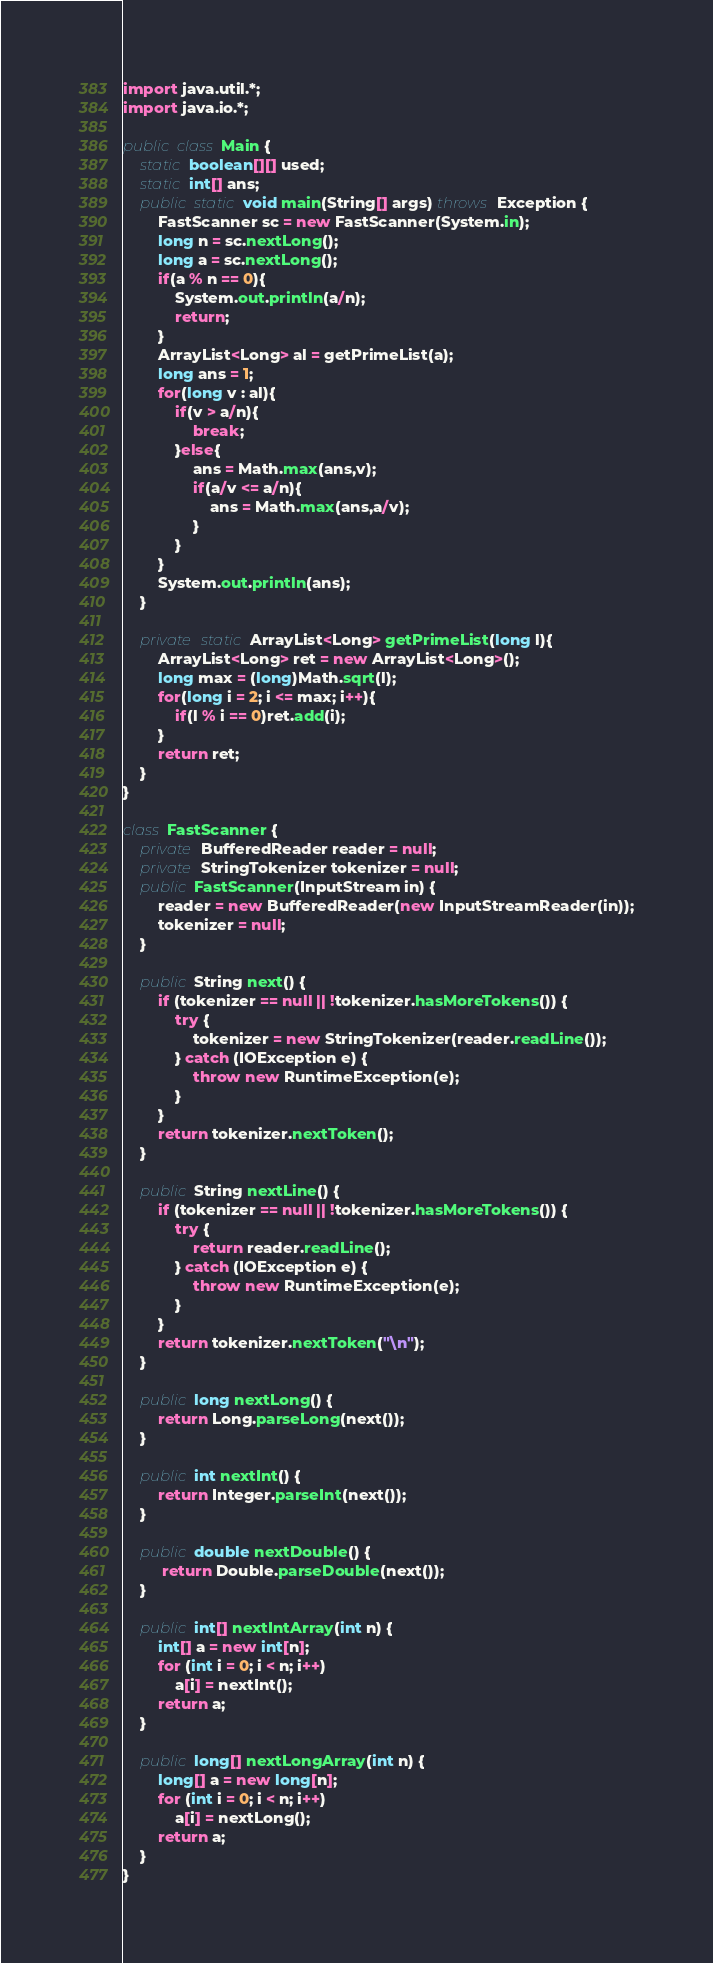Convert code to text. <code><loc_0><loc_0><loc_500><loc_500><_Java_>import java.util.*;
import java.io.*;
 
public class Main {
    static boolean[][] used;
    static int[] ans;
    public static void main(String[] args) throws Exception {
        FastScanner sc = new FastScanner(System.in);
        long n = sc.nextLong();
        long a = sc.nextLong();
        if(a % n == 0){
            System.out.println(a/n);
            return;
        }
        ArrayList<Long> al = getPrimeList(a);
        long ans = 1;
        for(long v : al){
            if(v > a/n){
                break;
            }else{
                ans = Math.max(ans,v);
                if(a/v <= a/n){
                    ans = Math.max(ans,a/v);
                }
            }
        }
        System.out.println(ans);
    }
    
    private static ArrayList<Long> getPrimeList(long l){
        ArrayList<Long> ret = new ArrayList<Long>();
        long max = (long)Math.sqrt(l);
        for(long i = 2; i <= max; i++){
            if(l % i == 0)ret.add(i);
        }
        return ret;
    }
}

class FastScanner {
    private BufferedReader reader = null;
    private StringTokenizer tokenizer = null;
    public FastScanner(InputStream in) {
        reader = new BufferedReader(new InputStreamReader(in));
        tokenizer = null;
    }

    public String next() {
        if (tokenizer == null || !tokenizer.hasMoreTokens()) {
            try {
                tokenizer = new StringTokenizer(reader.readLine());
            } catch (IOException e) {
                throw new RuntimeException(e);
            }
        }
        return tokenizer.nextToken();
    }

    public String nextLine() {
        if (tokenizer == null || !tokenizer.hasMoreTokens()) {
            try {
                return reader.readLine();
            } catch (IOException e) {
                throw new RuntimeException(e);
            }
        }
        return tokenizer.nextToken("\n");
    }

    public long nextLong() {
        return Long.parseLong(next());
    }

    public int nextInt() {
        return Integer.parseInt(next());
    }

    public double nextDouble() {
         return Double.parseDouble(next());
    }

    public int[] nextIntArray(int n) {
        int[] a = new int[n];
        for (int i = 0; i < n; i++)
            a[i] = nextInt();
        return a;
    }

    public long[] nextLongArray(int n) {
        long[] a = new long[n];
        for (int i = 0; i < n; i++)
            a[i] = nextLong();
        return a;
    } 
}
</code> 